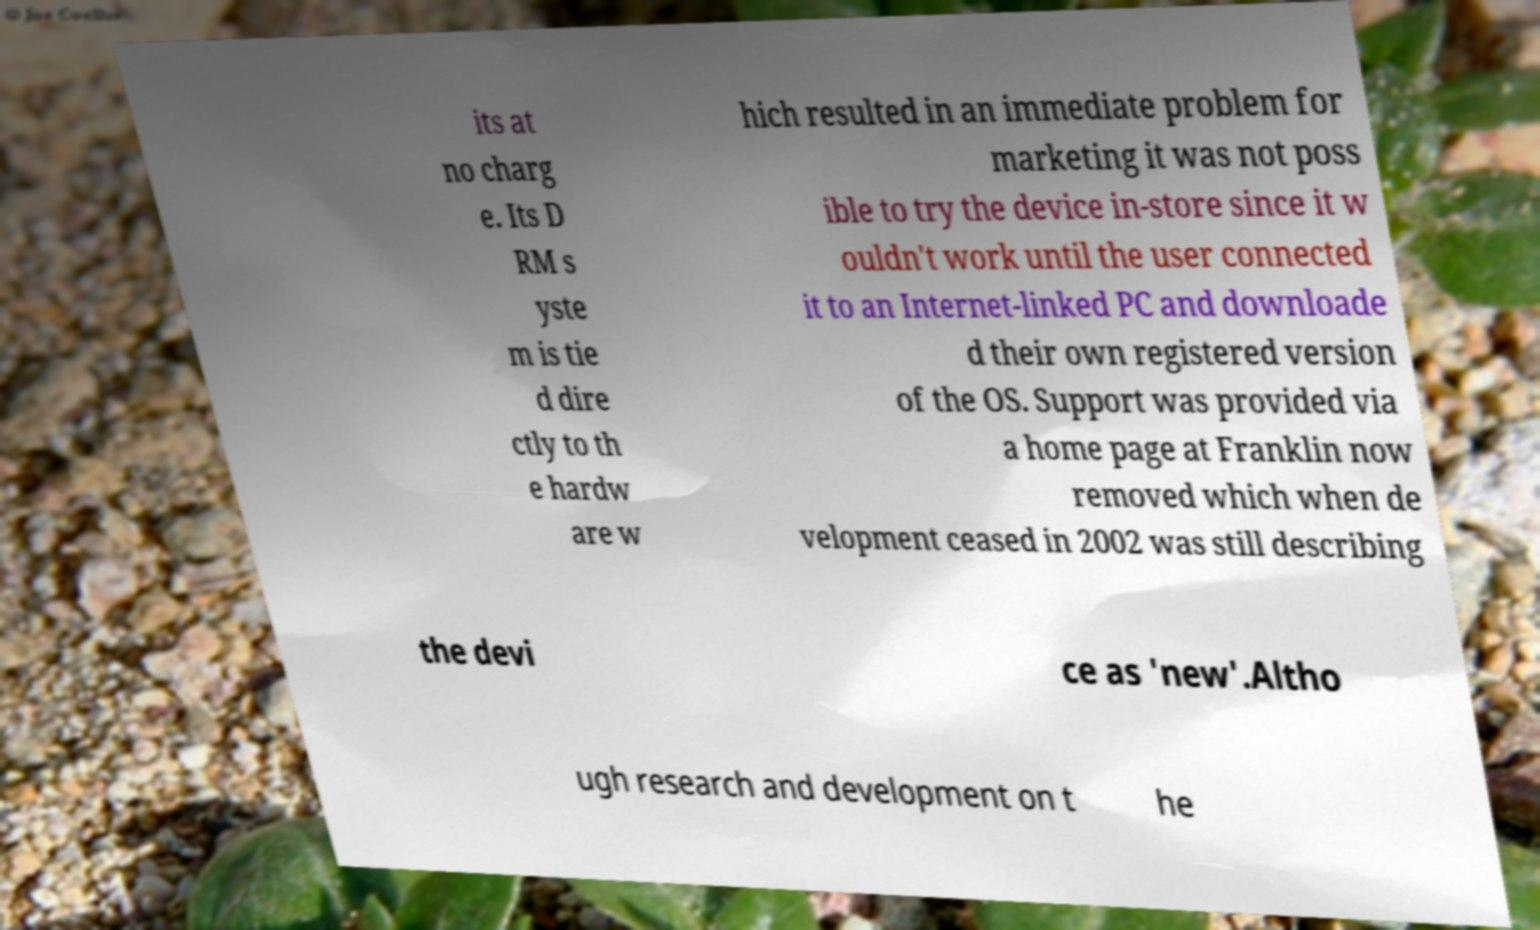I need the written content from this picture converted into text. Can you do that? its at no charg e. Its D RM s yste m is tie d dire ctly to th e hardw are w hich resulted in an immediate problem for marketing it was not poss ible to try the device in-store since it w ouldn't work until the user connected it to an Internet-linked PC and downloade d their own registered version of the OS. Support was provided via a home page at Franklin now removed which when de velopment ceased in 2002 was still describing the devi ce as 'new'.Altho ugh research and development on t he 